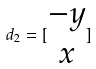Convert formula to latex. <formula><loc_0><loc_0><loc_500><loc_500>d _ { 2 } = [ \begin{matrix} - y \\ x \\ \end{matrix} ]</formula> 